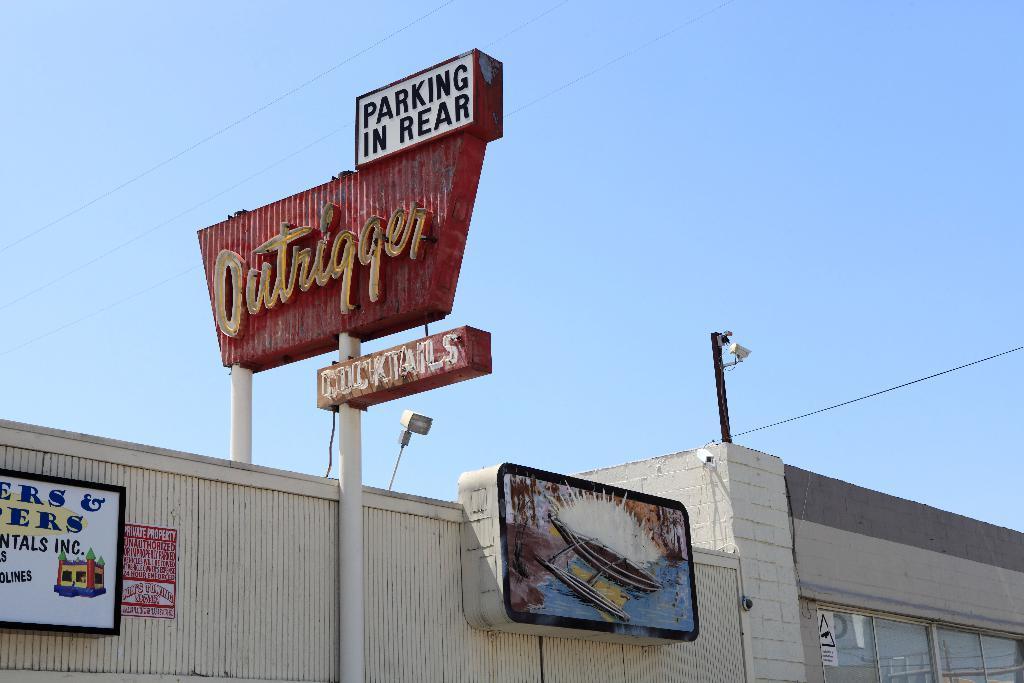Could you give a brief overview of what you see in this image? In this image at the bottom there are buildings, boards and on the boards there is text. And also there are some poles, wires and some lights and at the top there is sky. 